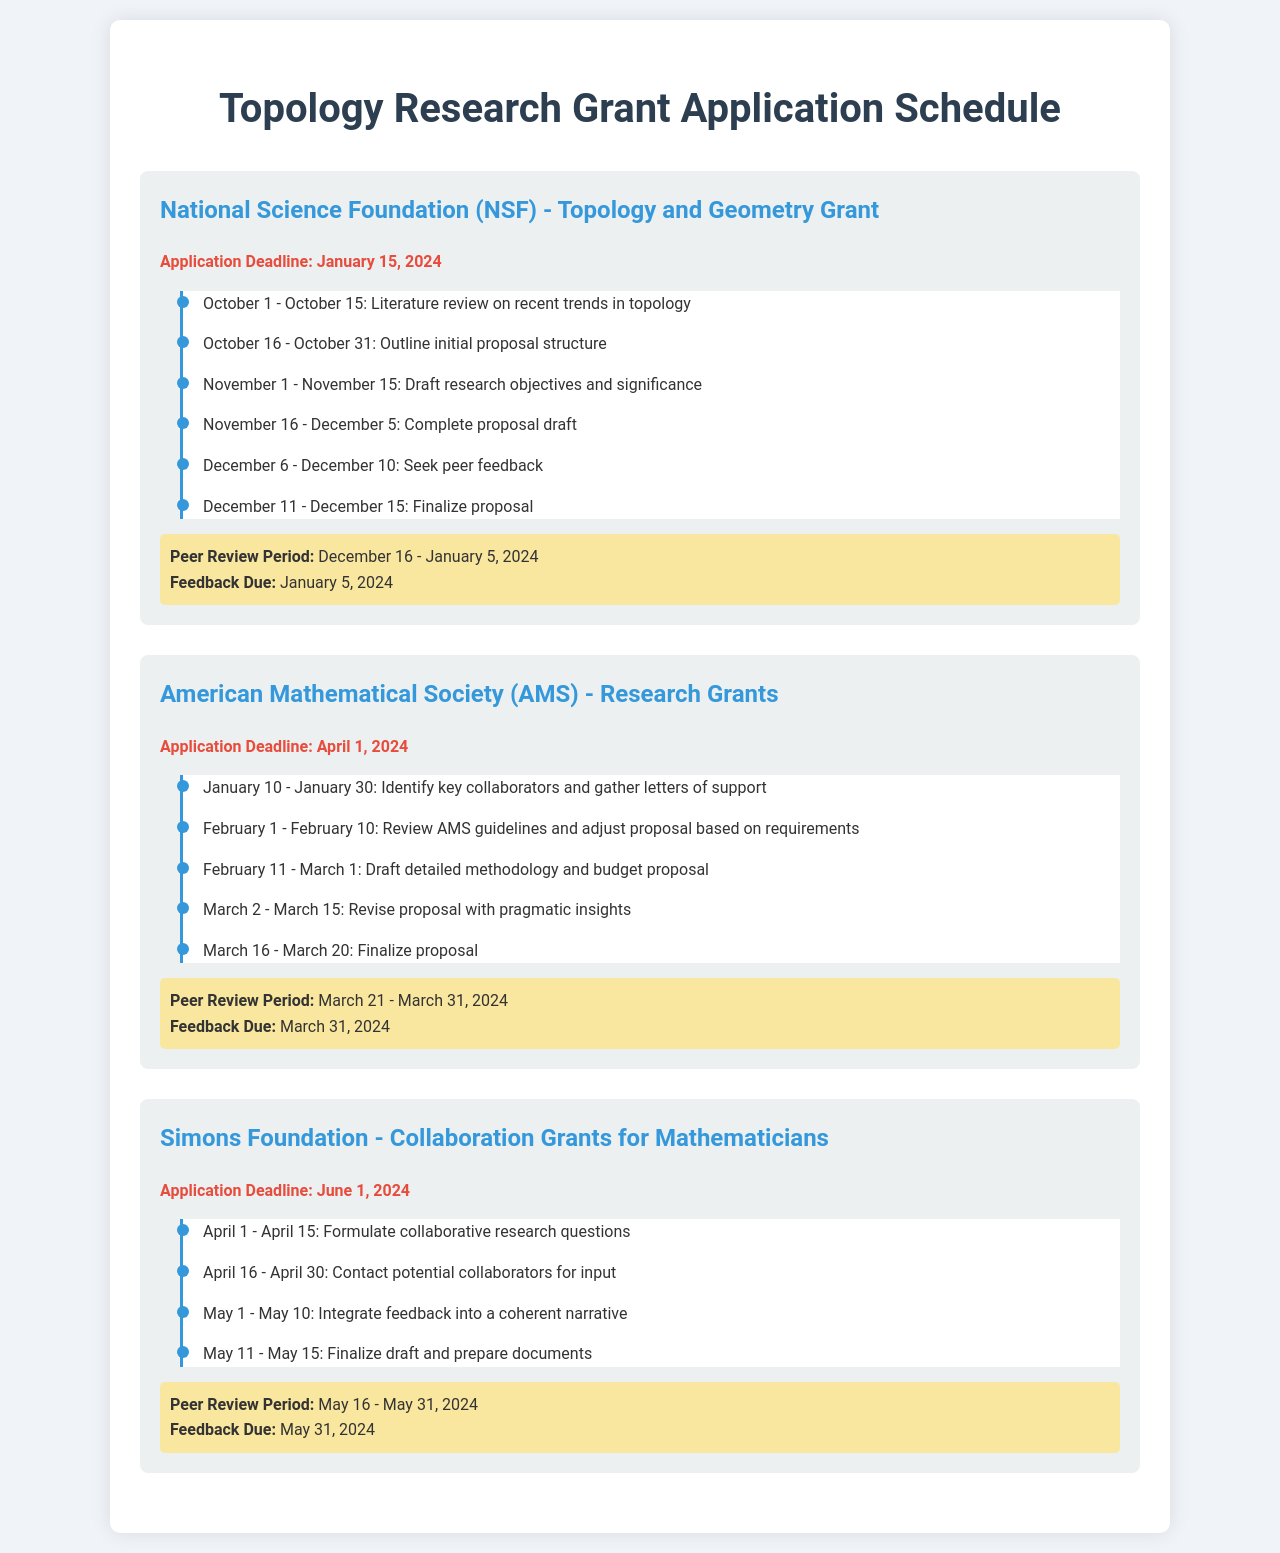What is the application deadline for the NSF grant? The application deadline is specifically stated in the document for the NSF grant.
Answer: January 15, 2024 What is the peer review period for the AMS grant? This period is detailed in the section of the AMS grant and provides key dates for review.
Answer: March 21 - March 31, 2024 When is the feedback due for the Simons Foundation grant? The document states a specific date for feedback submission regarding the Simons Foundation grant.
Answer: May 31, 2024 How long is the timeline for drafting the research objectives and significance for the NSF grant? This duration is clearly stated in the timeline section for the NSF grant.
Answer: November 1 - November 15 What is the first task to be completed for the AMS grant application? The document lists the initial tasks in the timeline for the AMS grant application.
Answer: Identify key collaborators and gather letters of support What period is allocated for seeking peer feedback for the NSF proposal? The timeline specifies the exact dates for seeking peer feedback in the NSF grant section.
Answer: December 6 - December 10 What is the deadline for finalizing the proposal for the NSF grant? The finalized date for the proposal is noted in the timeline for the NSF grant.
Answer: December 15 When should the proposal for the Simons Foundation grant be finalized? This information is given in the timeline and indicates when to complete the draft.
Answer: May 15 What task follows contacting potential collaborators for the Simons Foundation grant? According to the timeline, this task is listed after contacting collaborators.
Answer: Integrate feedback into a coherent narrative 